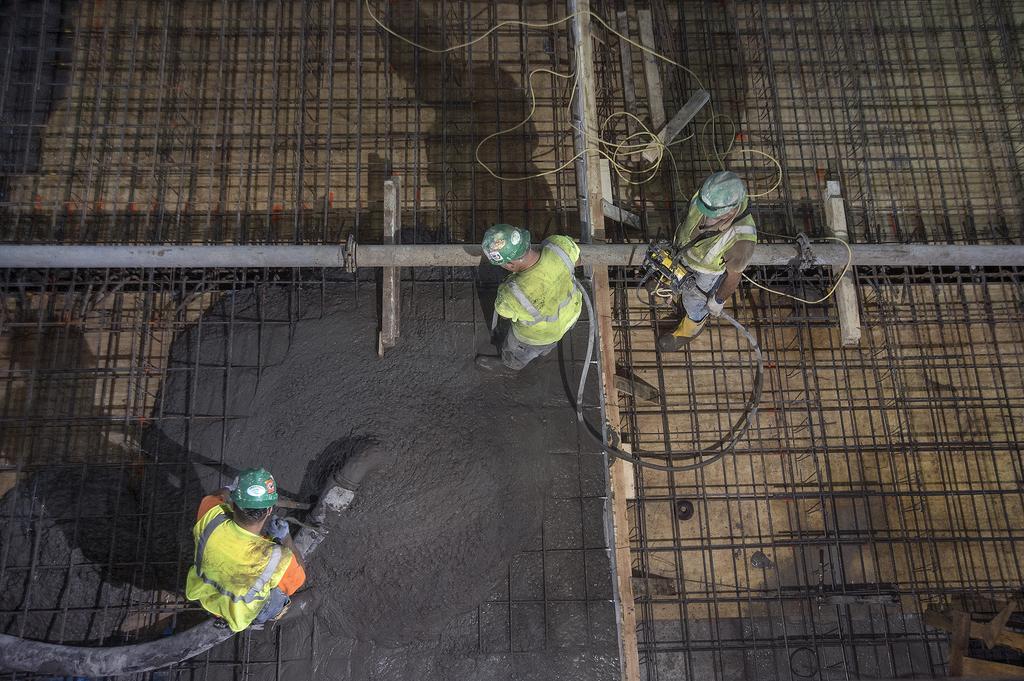Describe this image in one or two sentences. This image consists of a three men. On the left, the man is holding a concrete pipe. At the bottom, there are iron rods and concrete. All are wearing the helmets. 